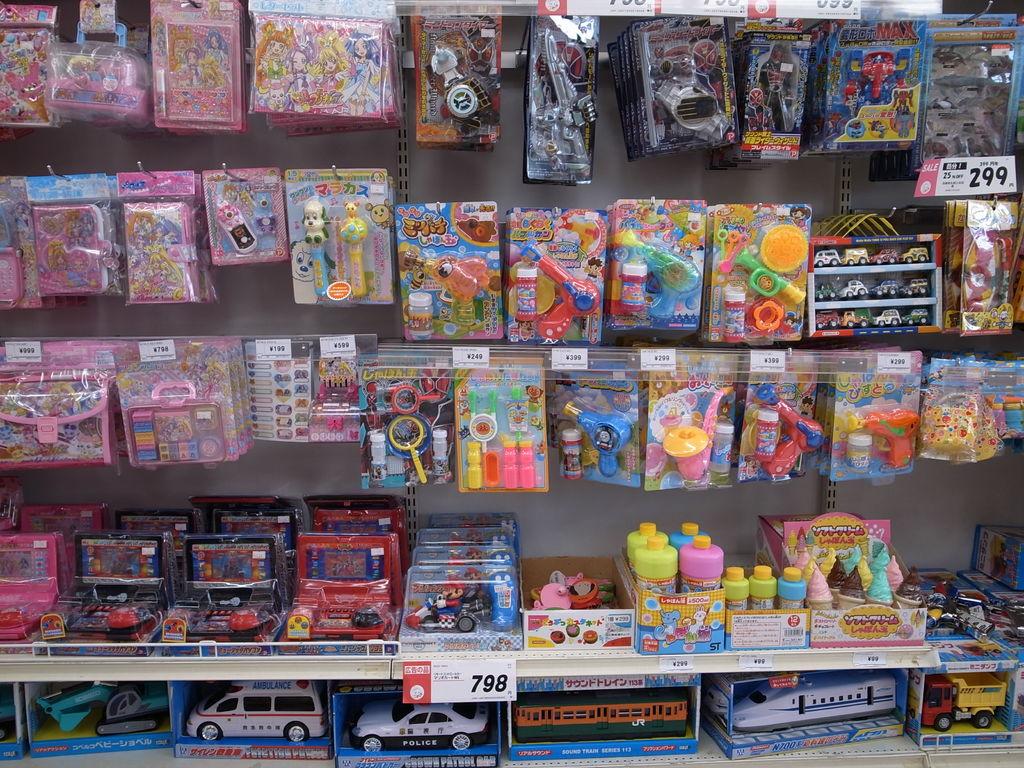How much does the mario kart toy cost?
Provide a short and direct response. 798. 